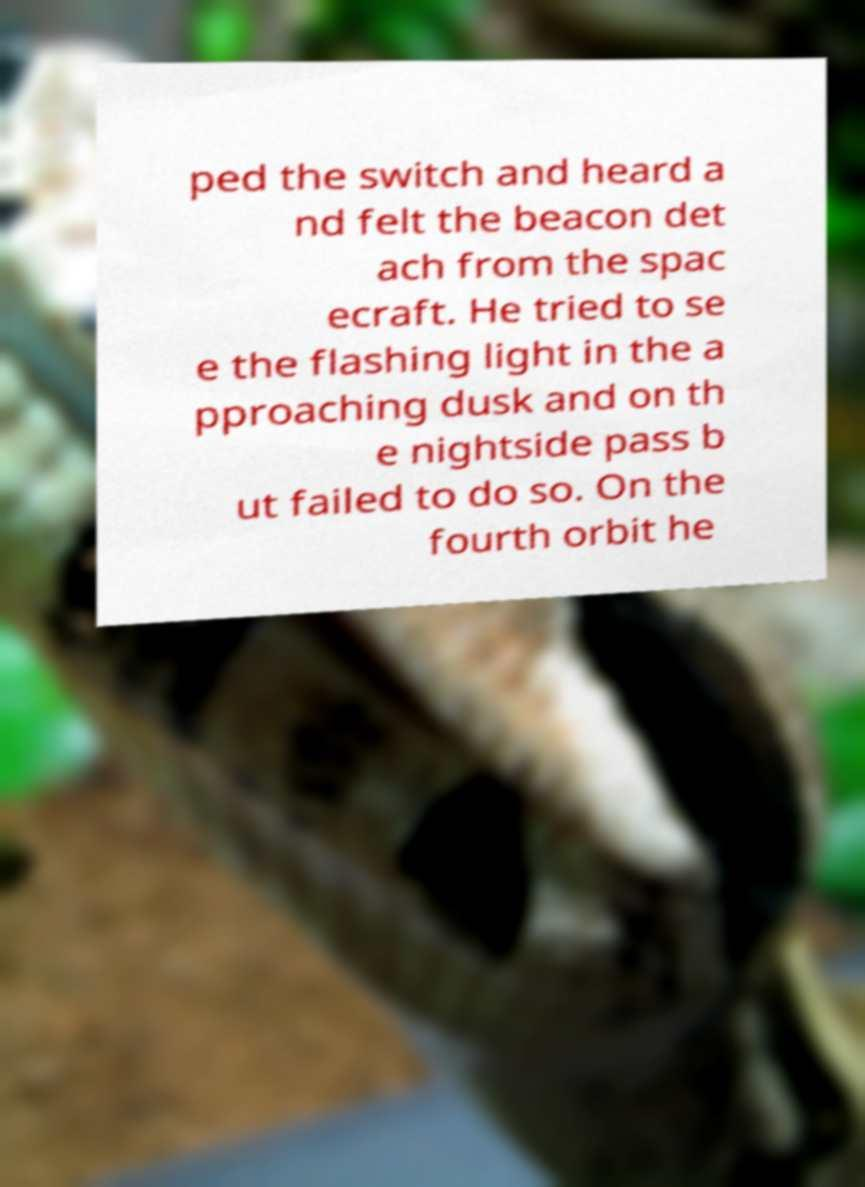Please identify and transcribe the text found in this image. ped the switch and heard a nd felt the beacon det ach from the spac ecraft. He tried to se e the flashing light in the a pproaching dusk and on th e nightside pass b ut failed to do so. On the fourth orbit he 